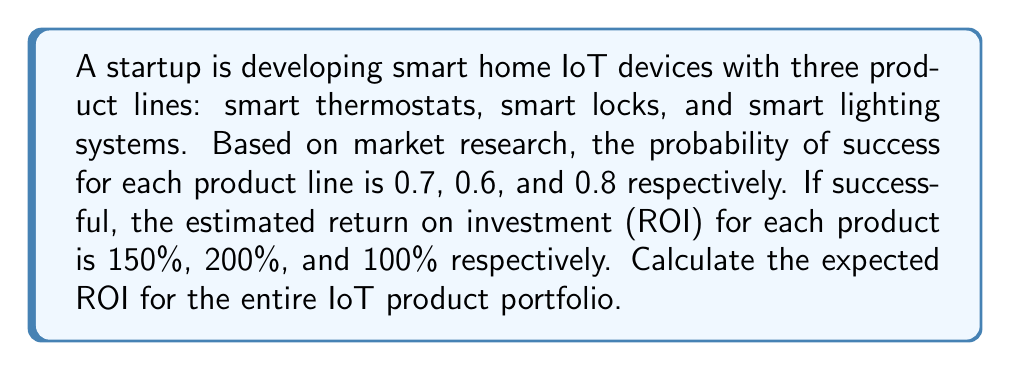Help me with this question. To solve this problem, we'll use probability theory and the concept of expected value. Let's break it down step-by-step:

1. Define variables:
   Let $R_t$, $R_l$, and $R_s$ be the ROI for thermostats, locks, and lighting systems respectively.
   Let $P_t$, $P_l$, and $P_s$ be the probability of success for each product.

2. Given information:
   $P_t = 0.7$, $P_l = 0.6$, $P_s = 0.8$
   $R_t = 150\%$, $R_l = 200\%$, $R_s = 100\%$

3. Calculate the expected ROI for each product:
   Expected ROI = Probability of Success × ROI if Successful + Probability of Failure × ROI if Failed
   
   For thermostats: $E(R_t) = 0.7 \times 150\% + 0.3 \times 0\% = 105\%$
   For locks: $E(R_l) = 0.6 \times 200\% + 0.4 \times 0\% = 120\%$
   For lighting: $E(R_s) = 0.8 \times 100\% + 0.2 \times 0\% = 80\%$

4. Calculate the total expected ROI:
   Assuming equal investment in each product line, the total expected ROI is the average of the individual expected ROIs:

   $$E(R_{total}) = \frac{E(R_t) + E(R_l) + E(R_s)}{3}$$

   $$E(R_{total}) = \frac{105\% + 120\% + 80\%}{3} = \frac{305\%}{3} = 101.67\%$$

Therefore, the expected ROI for the entire IoT product portfolio is 101.67%.
Answer: 101.67% 